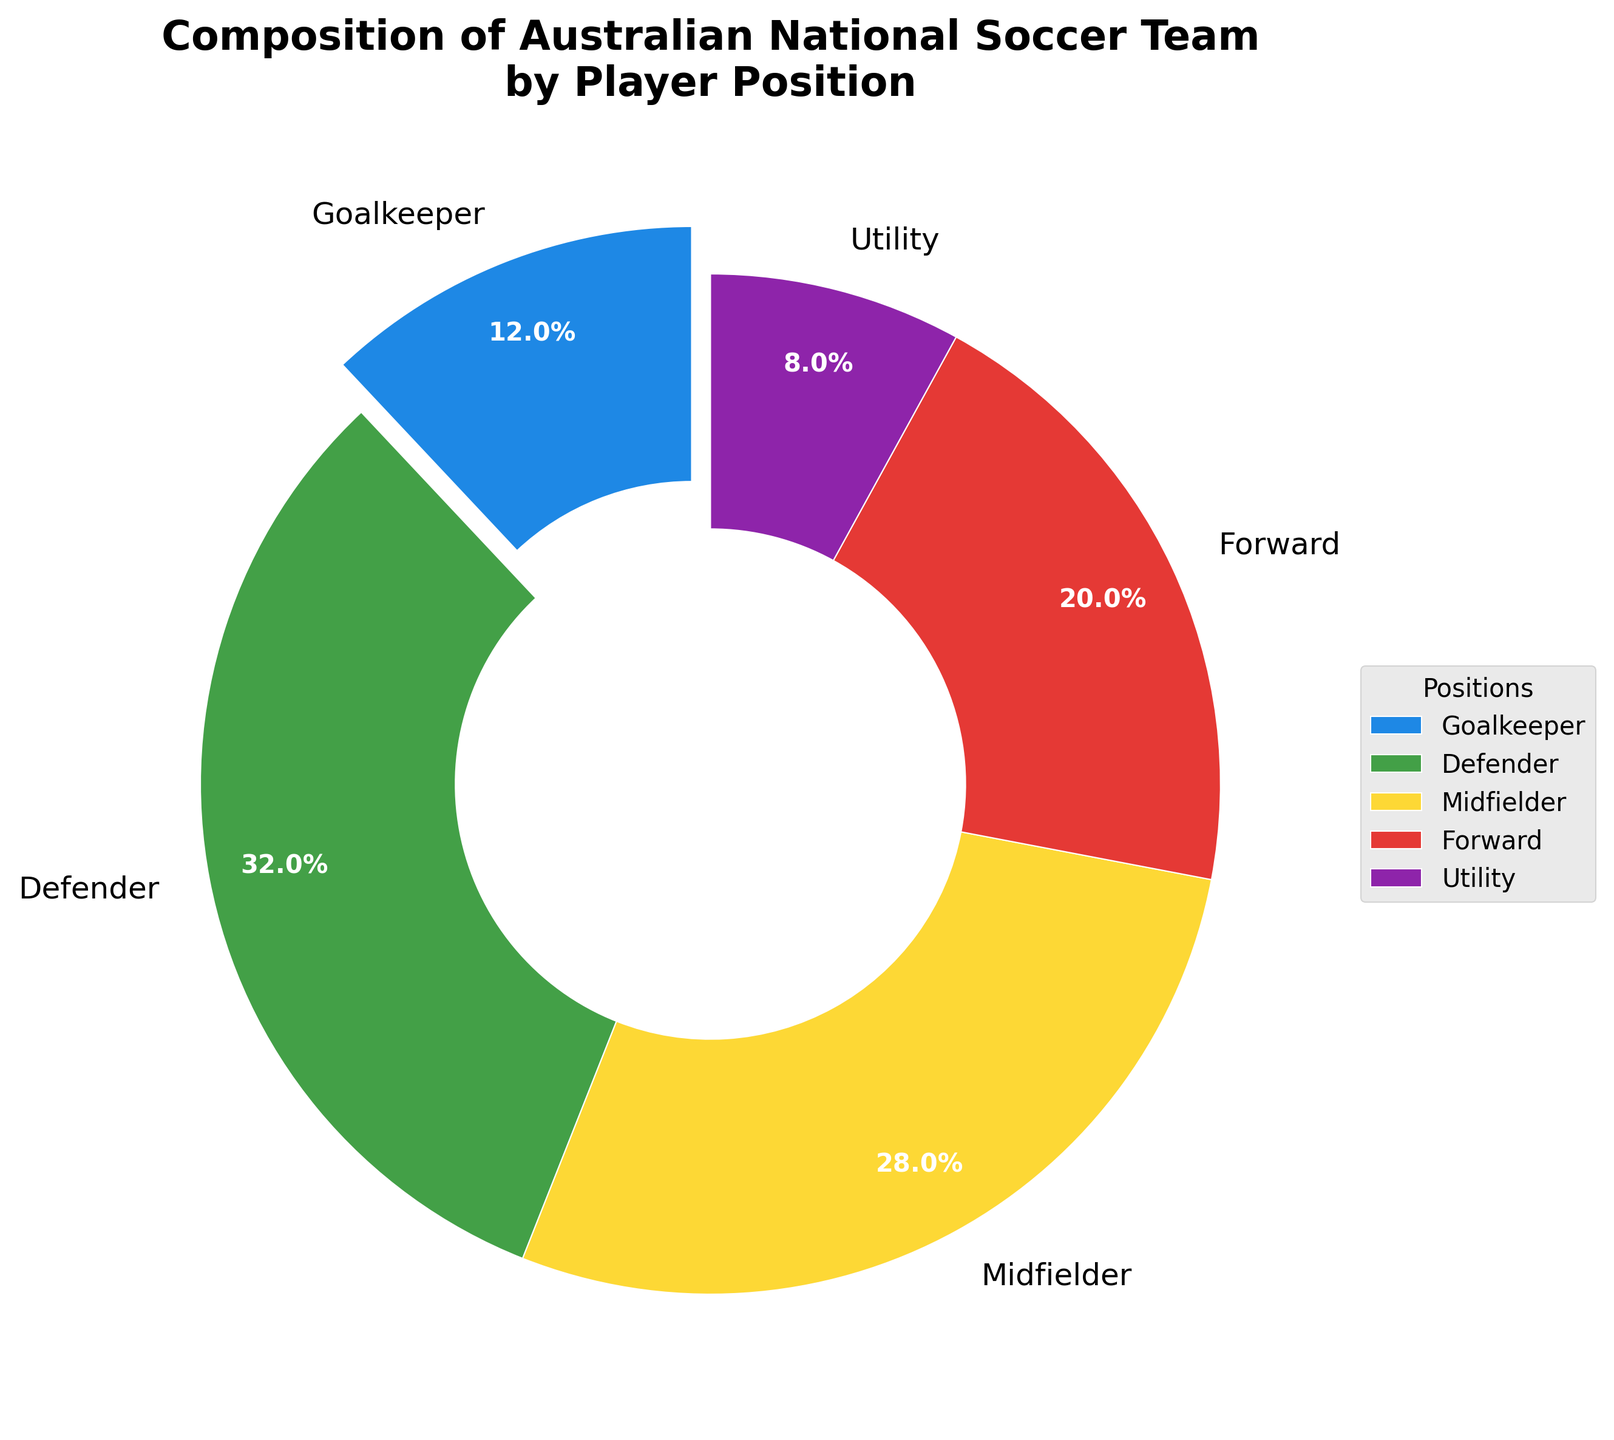What percentage of the team is made up of goalkeepers? The figure shows that goalkeepers make up 10% of the team.
Answer: 10% Which player position comprises the largest portion of the team? The figure indicates that defenders form the largest part of the team.
Answer: Defenders What is the total percentage of midfielders and forwards combined? Midfielders make up 23.3% and forwards 16.7% of the team. Adding these gives 23.3% + 16.7% = 40%.
Answer: 40% Is the number of defenders greater than the combined number of goalkeepers and forwards? The number of defenders is 8, while the combined number of goalkeepers (3) and forwards (5) is 8. Therefore, they are equal.
Answer: No, they are equal What fraction of the team are utility players? Utility players make up 6.7% of the team. Converting this percentage to a fraction gives 6.7% = 0.067, which approximates to 2/30 = 1/15 when simplified.
Answer: 1/15 Are there more midfielders or forwards? The figure shows there are 7 midfielders and 5 forwards. Thus, there are more midfielders.
Answer: Midfielders What are the three dominant colors visible in the pie chart? The figure uses primarily blue, green, and yellow colors for different sections of the chart.
Answer: Blue, green, yellow What is the angle corresponding to the defenders' section in the pie chart? The percentage of defenders is 26.7%. To find the angle, multiply 26.7% by 360 degrees: 26.7% * 360 = 96.12 degrees.
Answer: 96.12 degrees Which positions are represented by the smallest proportions in the pie chart? The two smallest sections in the pie chart are for goalkeepers and utility players.
Answer: Goalkeepers and Utility Players 